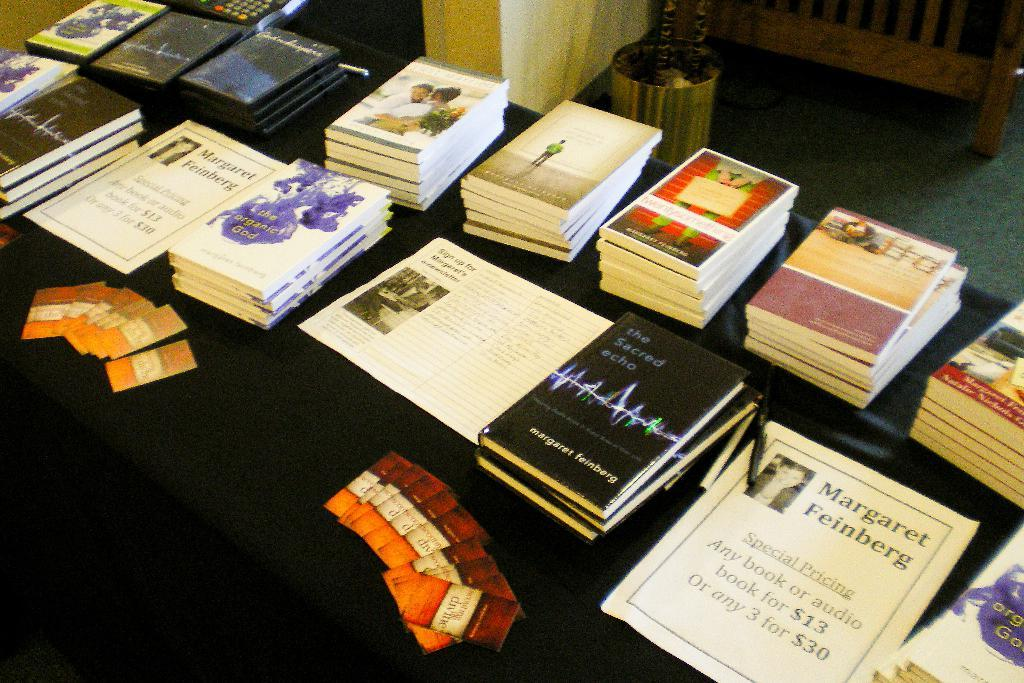<image>
Offer a succinct explanation of the picture presented. A book titled The Sacred Echo sits on a table, 